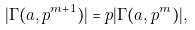<formula> <loc_0><loc_0><loc_500><loc_500>| \Gamma ( a , p ^ { m + 1 } ) | = p | \Gamma ( a , p ^ { m } ) | ,</formula> 